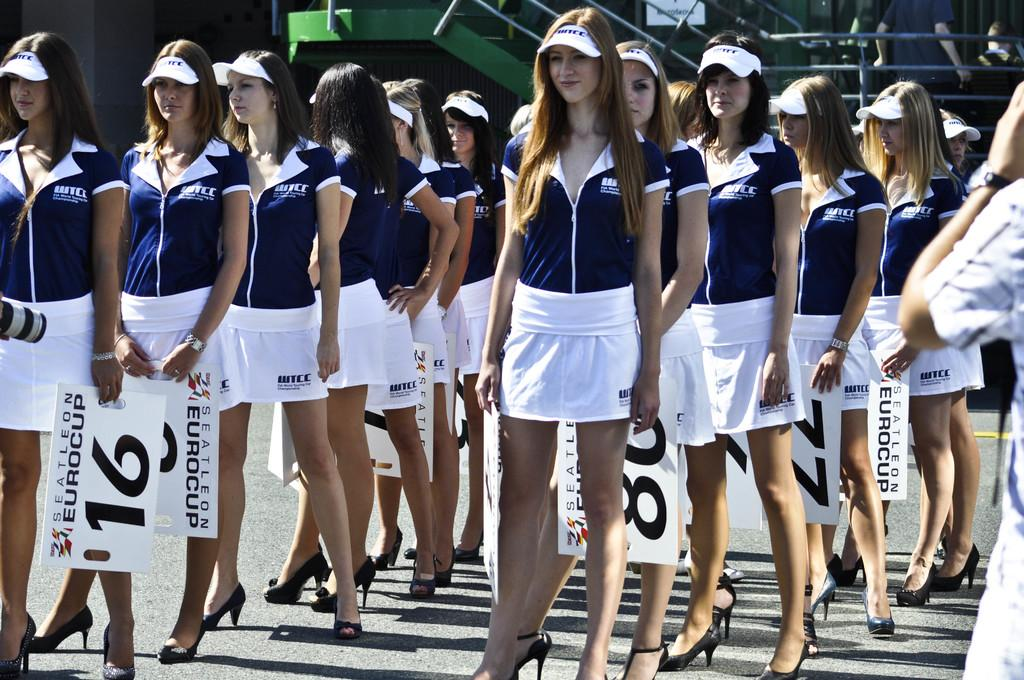<image>
Write a terse but informative summary of the picture. Line of women standing and holding numbers like the number 16. 